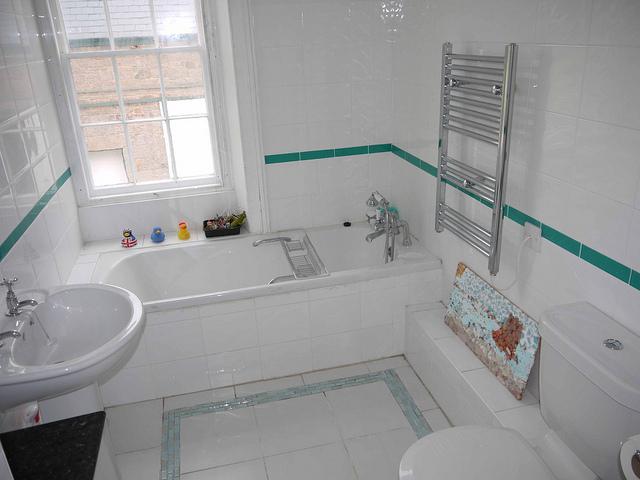Is the window open?
Quick response, please. No. Is this bathroom clean?
Quick response, please. Yes. What is the metal rack on the side wall used for?
Be succinct. Towels. Is there a mirror?
Short answer required. No. Is the view from the window real?
Write a very short answer. Yes. Is there any trash in the bathtub?
Answer briefly. No. Are there any shampoos next to the sink?
Write a very short answer. No. What color strip is on the tile?
Concise answer only. Green. Is there a shower in the bathroom?
Be succinct. No. 